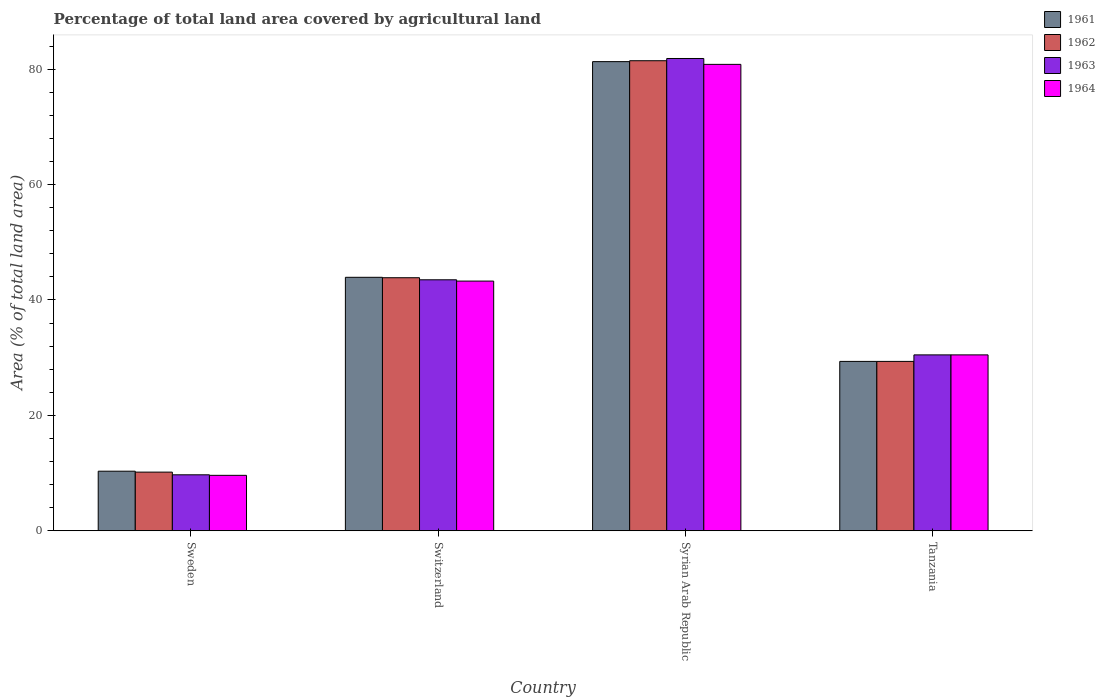How many different coloured bars are there?
Ensure brevity in your answer.  4. How many groups of bars are there?
Offer a terse response. 4. Are the number of bars on each tick of the X-axis equal?
Offer a terse response. Yes. What is the label of the 2nd group of bars from the left?
Offer a terse response. Switzerland. What is the percentage of agricultural land in 1963 in Tanzania?
Ensure brevity in your answer.  30.48. Across all countries, what is the maximum percentage of agricultural land in 1963?
Keep it short and to the point. 81.84. Across all countries, what is the minimum percentage of agricultural land in 1961?
Provide a succinct answer. 10.33. In which country was the percentage of agricultural land in 1962 maximum?
Provide a succinct answer. Syrian Arab Republic. In which country was the percentage of agricultural land in 1964 minimum?
Your answer should be compact. Sweden. What is the total percentage of agricultural land in 1964 in the graph?
Provide a short and direct response. 164.19. What is the difference between the percentage of agricultural land in 1964 in Sweden and that in Tanzania?
Ensure brevity in your answer.  -20.87. What is the difference between the percentage of agricultural land in 1962 in Switzerland and the percentage of agricultural land in 1964 in Syrian Arab Republic?
Your answer should be very brief. -36.97. What is the average percentage of agricultural land in 1964 per country?
Your response must be concise. 41.05. What is the difference between the percentage of agricultural land of/in 1963 and percentage of agricultural land of/in 1962 in Switzerland?
Ensure brevity in your answer.  -0.36. In how many countries, is the percentage of agricultural land in 1964 greater than 72 %?
Offer a terse response. 1. What is the ratio of the percentage of agricultural land in 1961 in Switzerland to that in Syrian Arab Republic?
Ensure brevity in your answer.  0.54. Is the percentage of agricultural land in 1963 in Sweden less than that in Switzerland?
Make the answer very short. Yes. Is the difference between the percentage of agricultural land in 1963 in Sweden and Switzerland greater than the difference between the percentage of agricultural land in 1962 in Sweden and Switzerland?
Make the answer very short. No. What is the difference between the highest and the second highest percentage of agricultural land in 1963?
Make the answer very short. 38.35. What is the difference between the highest and the lowest percentage of agricultural land in 1963?
Keep it short and to the point. 72.14. Is the sum of the percentage of agricultural land in 1961 in Sweden and Switzerland greater than the maximum percentage of agricultural land in 1963 across all countries?
Keep it short and to the point. No. Is it the case that in every country, the sum of the percentage of agricultural land in 1964 and percentage of agricultural land in 1961 is greater than the sum of percentage of agricultural land in 1962 and percentage of agricultural land in 1963?
Provide a short and direct response. No. What does the 2nd bar from the left in Switzerland represents?
Give a very brief answer. 1962. What does the 1st bar from the right in Sweden represents?
Provide a succinct answer. 1964. Are the values on the major ticks of Y-axis written in scientific E-notation?
Offer a very short reply. No. Does the graph contain any zero values?
Provide a succinct answer. No. What is the title of the graph?
Provide a succinct answer. Percentage of total land area covered by agricultural land. What is the label or title of the Y-axis?
Provide a succinct answer. Area (% of total land area). What is the Area (% of total land area) of 1961 in Sweden?
Keep it short and to the point. 10.33. What is the Area (% of total land area) in 1962 in Sweden?
Provide a succinct answer. 10.17. What is the Area (% of total land area) in 1963 in Sweden?
Your answer should be compact. 9.7. What is the Area (% of total land area) of 1964 in Sweden?
Offer a very short reply. 9.61. What is the Area (% of total land area) in 1961 in Switzerland?
Offer a terse response. 43.93. What is the Area (% of total land area) in 1962 in Switzerland?
Your response must be concise. 43.85. What is the Area (% of total land area) of 1963 in Switzerland?
Ensure brevity in your answer.  43.49. What is the Area (% of total land area) in 1964 in Switzerland?
Ensure brevity in your answer.  43.27. What is the Area (% of total land area) of 1961 in Syrian Arab Republic?
Your response must be concise. 81.3. What is the Area (% of total land area) of 1962 in Syrian Arab Republic?
Your response must be concise. 81.46. What is the Area (% of total land area) of 1963 in Syrian Arab Republic?
Offer a very short reply. 81.84. What is the Area (% of total land area) in 1964 in Syrian Arab Republic?
Provide a succinct answer. 80.82. What is the Area (% of total land area) in 1961 in Tanzania?
Provide a short and direct response. 29.35. What is the Area (% of total land area) of 1962 in Tanzania?
Your response must be concise. 29.35. What is the Area (% of total land area) of 1963 in Tanzania?
Give a very brief answer. 30.48. What is the Area (% of total land area) in 1964 in Tanzania?
Offer a terse response. 30.48. Across all countries, what is the maximum Area (% of total land area) of 1961?
Your answer should be compact. 81.3. Across all countries, what is the maximum Area (% of total land area) of 1962?
Make the answer very short. 81.46. Across all countries, what is the maximum Area (% of total land area) in 1963?
Provide a short and direct response. 81.84. Across all countries, what is the maximum Area (% of total land area) of 1964?
Keep it short and to the point. 80.82. Across all countries, what is the minimum Area (% of total land area) in 1961?
Your answer should be compact. 10.33. Across all countries, what is the minimum Area (% of total land area) of 1962?
Provide a short and direct response. 10.17. Across all countries, what is the minimum Area (% of total land area) in 1963?
Offer a terse response. 9.7. Across all countries, what is the minimum Area (% of total land area) of 1964?
Your response must be concise. 9.61. What is the total Area (% of total land area) in 1961 in the graph?
Provide a short and direct response. 164.9. What is the total Area (% of total land area) of 1962 in the graph?
Your response must be concise. 164.83. What is the total Area (% of total land area) of 1963 in the graph?
Make the answer very short. 165.52. What is the total Area (% of total land area) in 1964 in the graph?
Your answer should be very brief. 164.19. What is the difference between the Area (% of total land area) of 1961 in Sweden and that in Switzerland?
Keep it short and to the point. -33.6. What is the difference between the Area (% of total land area) in 1962 in Sweden and that in Switzerland?
Provide a succinct answer. -33.69. What is the difference between the Area (% of total land area) of 1963 in Sweden and that in Switzerland?
Make the answer very short. -33.79. What is the difference between the Area (% of total land area) in 1964 in Sweden and that in Switzerland?
Provide a short and direct response. -33.66. What is the difference between the Area (% of total land area) in 1961 in Sweden and that in Syrian Arab Republic?
Your response must be concise. -70.97. What is the difference between the Area (% of total land area) of 1962 in Sweden and that in Syrian Arab Republic?
Your response must be concise. -71.29. What is the difference between the Area (% of total land area) in 1963 in Sweden and that in Syrian Arab Republic?
Your response must be concise. -72.14. What is the difference between the Area (% of total land area) of 1964 in Sweden and that in Syrian Arab Republic?
Ensure brevity in your answer.  -71.22. What is the difference between the Area (% of total land area) of 1961 in Sweden and that in Tanzania?
Provide a succinct answer. -19.03. What is the difference between the Area (% of total land area) of 1962 in Sweden and that in Tanzania?
Make the answer very short. -19.18. What is the difference between the Area (% of total land area) of 1963 in Sweden and that in Tanzania?
Make the answer very short. -20.78. What is the difference between the Area (% of total land area) of 1964 in Sweden and that in Tanzania?
Keep it short and to the point. -20.87. What is the difference between the Area (% of total land area) of 1961 in Switzerland and that in Syrian Arab Republic?
Your response must be concise. -37.37. What is the difference between the Area (% of total land area) in 1962 in Switzerland and that in Syrian Arab Republic?
Provide a short and direct response. -37.6. What is the difference between the Area (% of total land area) of 1963 in Switzerland and that in Syrian Arab Republic?
Ensure brevity in your answer.  -38.35. What is the difference between the Area (% of total land area) in 1964 in Switzerland and that in Syrian Arab Republic?
Your answer should be compact. -37.55. What is the difference between the Area (% of total land area) of 1961 in Switzerland and that in Tanzania?
Provide a short and direct response. 14.57. What is the difference between the Area (% of total land area) of 1962 in Switzerland and that in Tanzania?
Your answer should be compact. 14.5. What is the difference between the Area (% of total land area) of 1963 in Switzerland and that in Tanzania?
Your answer should be very brief. 13.01. What is the difference between the Area (% of total land area) of 1964 in Switzerland and that in Tanzania?
Your answer should be compact. 12.79. What is the difference between the Area (% of total land area) in 1961 in Syrian Arab Republic and that in Tanzania?
Give a very brief answer. 51.95. What is the difference between the Area (% of total land area) of 1962 in Syrian Arab Republic and that in Tanzania?
Provide a short and direct response. 52.1. What is the difference between the Area (% of total land area) in 1963 in Syrian Arab Republic and that in Tanzania?
Make the answer very short. 51.36. What is the difference between the Area (% of total land area) of 1964 in Syrian Arab Republic and that in Tanzania?
Ensure brevity in your answer.  50.34. What is the difference between the Area (% of total land area) in 1961 in Sweden and the Area (% of total land area) in 1962 in Switzerland?
Provide a succinct answer. -33.53. What is the difference between the Area (% of total land area) of 1961 in Sweden and the Area (% of total land area) of 1963 in Switzerland?
Provide a succinct answer. -33.17. What is the difference between the Area (% of total land area) in 1961 in Sweden and the Area (% of total land area) in 1964 in Switzerland?
Give a very brief answer. -32.95. What is the difference between the Area (% of total land area) in 1962 in Sweden and the Area (% of total land area) in 1963 in Switzerland?
Give a very brief answer. -33.33. What is the difference between the Area (% of total land area) in 1962 in Sweden and the Area (% of total land area) in 1964 in Switzerland?
Make the answer very short. -33.1. What is the difference between the Area (% of total land area) of 1963 in Sweden and the Area (% of total land area) of 1964 in Switzerland?
Your answer should be compact. -33.57. What is the difference between the Area (% of total land area) in 1961 in Sweden and the Area (% of total land area) in 1962 in Syrian Arab Republic?
Provide a short and direct response. -71.13. What is the difference between the Area (% of total land area) of 1961 in Sweden and the Area (% of total land area) of 1963 in Syrian Arab Republic?
Your answer should be compact. -71.52. What is the difference between the Area (% of total land area) in 1961 in Sweden and the Area (% of total land area) in 1964 in Syrian Arab Republic?
Provide a succinct answer. -70.5. What is the difference between the Area (% of total land area) of 1962 in Sweden and the Area (% of total land area) of 1963 in Syrian Arab Republic?
Make the answer very short. -71.68. What is the difference between the Area (% of total land area) of 1962 in Sweden and the Area (% of total land area) of 1964 in Syrian Arab Republic?
Offer a terse response. -70.66. What is the difference between the Area (% of total land area) in 1963 in Sweden and the Area (% of total land area) in 1964 in Syrian Arab Republic?
Make the answer very short. -71.12. What is the difference between the Area (% of total land area) in 1961 in Sweden and the Area (% of total land area) in 1962 in Tanzania?
Your answer should be very brief. -19.03. What is the difference between the Area (% of total land area) in 1961 in Sweden and the Area (% of total land area) in 1963 in Tanzania?
Offer a terse response. -20.16. What is the difference between the Area (% of total land area) of 1961 in Sweden and the Area (% of total land area) of 1964 in Tanzania?
Give a very brief answer. -20.16. What is the difference between the Area (% of total land area) in 1962 in Sweden and the Area (% of total land area) in 1963 in Tanzania?
Offer a very short reply. -20.31. What is the difference between the Area (% of total land area) of 1962 in Sweden and the Area (% of total land area) of 1964 in Tanzania?
Offer a very short reply. -20.31. What is the difference between the Area (% of total land area) in 1963 in Sweden and the Area (% of total land area) in 1964 in Tanzania?
Offer a terse response. -20.78. What is the difference between the Area (% of total land area) of 1961 in Switzerland and the Area (% of total land area) of 1962 in Syrian Arab Republic?
Offer a terse response. -37.53. What is the difference between the Area (% of total land area) of 1961 in Switzerland and the Area (% of total land area) of 1963 in Syrian Arab Republic?
Offer a very short reply. -37.92. What is the difference between the Area (% of total land area) of 1961 in Switzerland and the Area (% of total land area) of 1964 in Syrian Arab Republic?
Give a very brief answer. -36.9. What is the difference between the Area (% of total land area) of 1962 in Switzerland and the Area (% of total land area) of 1963 in Syrian Arab Republic?
Your answer should be compact. -37.99. What is the difference between the Area (% of total land area) in 1962 in Switzerland and the Area (% of total land area) in 1964 in Syrian Arab Republic?
Offer a very short reply. -36.97. What is the difference between the Area (% of total land area) in 1963 in Switzerland and the Area (% of total land area) in 1964 in Syrian Arab Republic?
Make the answer very short. -37.33. What is the difference between the Area (% of total land area) of 1961 in Switzerland and the Area (% of total land area) of 1962 in Tanzania?
Your answer should be compact. 14.57. What is the difference between the Area (% of total land area) in 1961 in Switzerland and the Area (% of total land area) in 1963 in Tanzania?
Offer a terse response. 13.44. What is the difference between the Area (% of total land area) of 1961 in Switzerland and the Area (% of total land area) of 1964 in Tanzania?
Your answer should be compact. 13.44. What is the difference between the Area (% of total land area) of 1962 in Switzerland and the Area (% of total land area) of 1963 in Tanzania?
Your response must be concise. 13.37. What is the difference between the Area (% of total land area) in 1962 in Switzerland and the Area (% of total land area) in 1964 in Tanzania?
Keep it short and to the point. 13.37. What is the difference between the Area (% of total land area) of 1963 in Switzerland and the Area (% of total land area) of 1964 in Tanzania?
Provide a succinct answer. 13.01. What is the difference between the Area (% of total land area) of 1961 in Syrian Arab Republic and the Area (% of total land area) of 1962 in Tanzania?
Keep it short and to the point. 51.95. What is the difference between the Area (% of total land area) of 1961 in Syrian Arab Republic and the Area (% of total land area) of 1963 in Tanzania?
Offer a terse response. 50.82. What is the difference between the Area (% of total land area) of 1961 in Syrian Arab Republic and the Area (% of total land area) of 1964 in Tanzania?
Ensure brevity in your answer.  50.82. What is the difference between the Area (% of total land area) of 1962 in Syrian Arab Republic and the Area (% of total land area) of 1963 in Tanzania?
Ensure brevity in your answer.  50.98. What is the difference between the Area (% of total land area) in 1962 in Syrian Arab Republic and the Area (% of total land area) in 1964 in Tanzania?
Ensure brevity in your answer.  50.98. What is the difference between the Area (% of total land area) in 1963 in Syrian Arab Republic and the Area (% of total land area) in 1964 in Tanzania?
Your answer should be compact. 51.36. What is the average Area (% of total land area) in 1961 per country?
Your answer should be very brief. 41.23. What is the average Area (% of total land area) in 1962 per country?
Your answer should be very brief. 41.21. What is the average Area (% of total land area) in 1963 per country?
Your answer should be very brief. 41.38. What is the average Area (% of total land area) in 1964 per country?
Offer a terse response. 41.05. What is the difference between the Area (% of total land area) in 1961 and Area (% of total land area) in 1962 in Sweden?
Ensure brevity in your answer.  0.16. What is the difference between the Area (% of total land area) of 1961 and Area (% of total land area) of 1963 in Sweden?
Make the answer very short. 0.62. What is the difference between the Area (% of total land area) in 1961 and Area (% of total land area) in 1964 in Sweden?
Keep it short and to the point. 0.72. What is the difference between the Area (% of total land area) in 1962 and Area (% of total land area) in 1963 in Sweden?
Keep it short and to the point. 0.47. What is the difference between the Area (% of total land area) of 1962 and Area (% of total land area) of 1964 in Sweden?
Give a very brief answer. 0.56. What is the difference between the Area (% of total land area) in 1963 and Area (% of total land area) in 1964 in Sweden?
Provide a short and direct response. 0.09. What is the difference between the Area (% of total land area) in 1961 and Area (% of total land area) in 1962 in Switzerland?
Your response must be concise. 0.07. What is the difference between the Area (% of total land area) of 1961 and Area (% of total land area) of 1963 in Switzerland?
Provide a short and direct response. 0.43. What is the difference between the Area (% of total land area) of 1961 and Area (% of total land area) of 1964 in Switzerland?
Give a very brief answer. 0.66. What is the difference between the Area (% of total land area) of 1962 and Area (% of total land area) of 1963 in Switzerland?
Keep it short and to the point. 0.36. What is the difference between the Area (% of total land area) in 1962 and Area (% of total land area) in 1964 in Switzerland?
Give a very brief answer. 0.58. What is the difference between the Area (% of total land area) of 1963 and Area (% of total land area) of 1964 in Switzerland?
Ensure brevity in your answer.  0.22. What is the difference between the Area (% of total land area) in 1961 and Area (% of total land area) in 1962 in Syrian Arab Republic?
Offer a very short reply. -0.16. What is the difference between the Area (% of total land area) in 1961 and Area (% of total land area) in 1963 in Syrian Arab Republic?
Your response must be concise. -0.54. What is the difference between the Area (% of total land area) in 1961 and Area (% of total land area) in 1964 in Syrian Arab Republic?
Your response must be concise. 0.47. What is the difference between the Area (% of total land area) in 1962 and Area (% of total land area) in 1963 in Syrian Arab Republic?
Your response must be concise. -0.39. What is the difference between the Area (% of total land area) of 1962 and Area (% of total land area) of 1964 in Syrian Arab Republic?
Offer a very short reply. 0.63. What is the difference between the Area (% of total land area) of 1963 and Area (% of total land area) of 1964 in Syrian Arab Republic?
Provide a short and direct response. 1.02. What is the difference between the Area (% of total land area) of 1961 and Area (% of total land area) of 1963 in Tanzania?
Keep it short and to the point. -1.13. What is the difference between the Area (% of total land area) of 1961 and Area (% of total land area) of 1964 in Tanzania?
Keep it short and to the point. -1.13. What is the difference between the Area (% of total land area) of 1962 and Area (% of total land area) of 1963 in Tanzania?
Give a very brief answer. -1.13. What is the difference between the Area (% of total land area) in 1962 and Area (% of total land area) in 1964 in Tanzania?
Offer a terse response. -1.13. What is the difference between the Area (% of total land area) of 1963 and Area (% of total land area) of 1964 in Tanzania?
Offer a very short reply. 0. What is the ratio of the Area (% of total land area) in 1961 in Sweden to that in Switzerland?
Keep it short and to the point. 0.24. What is the ratio of the Area (% of total land area) in 1962 in Sweden to that in Switzerland?
Offer a very short reply. 0.23. What is the ratio of the Area (% of total land area) in 1963 in Sweden to that in Switzerland?
Your answer should be very brief. 0.22. What is the ratio of the Area (% of total land area) in 1964 in Sweden to that in Switzerland?
Your answer should be compact. 0.22. What is the ratio of the Area (% of total land area) of 1961 in Sweden to that in Syrian Arab Republic?
Provide a succinct answer. 0.13. What is the ratio of the Area (% of total land area) in 1962 in Sweden to that in Syrian Arab Republic?
Provide a succinct answer. 0.12. What is the ratio of the Area (% of total land area) of 1963 in Sweden to that in Syrian Arab Republic?
Provide a short and direct response. 0.12. What is the ratio of the Area (% of total land area) in 1964 in Sweden to that in Syrian Arab Republic?
Provide a short and direct response. 0.12. What is the ratio of the Area (% of total land area) of 1961 in Sweden to that in Tanzania?
Give a very brief answer. 0.35. What is the ratio of the Area (% of total land area) in 1962 in Sweden to that in Tanzania?
Offer a very short reply. 0.35. What is the ratio of the Area (% of total land area) in 1963 in Sweden to that in Tanzania?
Ensure brevity in your answer.  0.32. What is the ratio of the Area (% of total land area) in 1964 in Sweden to that in Tanzania?
Give a very brief answer. 0.32. What is the ratio of the Area (% of total land area) of 1961 in Switzerland to that in Syrian Arab Republic?
Ensure brevity in your answer.  0.54. What is the ratio of the Area (% of total land area) in 1962 in Switzerland to that in Syrian Arab Republic?
Make the answer very short. 0.54. What is the ratio of the Area (% of total land area) of 1963 in Switzerland to that in Syrian Arab Republic?
Provide a succinct answer. 0.53. What is the ratio of the Area (% of total land area) of 1964 in Switzerland to that in Syrian Arab Republic?
Your answer should be very brief. 0.54. What is the ratio of the Area (% of total land area) of 1961 in Switzerland to that in Tanzania?
Your answer should be very brief. 1.5. What is the ratio of the Area (% of total land area) in 1962 in Switzerland to that in Tanzania?
Make the answer very short. 1.49. What is the ratio of the Area (% of total land area) of 1963 in Switzerland to that in Tanzania?
Your response must be concise. 1.43. What is the ratio of the Area (% of total land area) of 1964 in Switzerland to that in Tanzania?
Keep it short and to the point. 1.42. What is the ratio of the Area (% of total land area) in 1961 in Syrian Arab Republic to that in Tanzania?
Provide a succinct answer. 2.77. What is the ratio of the Area (% of total land area) of 1962 in Syrian Arab Republic to that in Tanzania?
Offer a terse response. 2.78. What is the ratio of the Area (% of total land area) of 1963 in Syrian Arab Republic to that in Tanzania?
Make the answer very short. 2.69. What is the ratio of the Area (% of total land area) of 1964 in Syrian Arab Republic to that in Tanzania?
Your answer should be compact. 2.65. What is the difference between the highest and the second highest Area (% of total land area) of 1961?
Keep it short and to the point. 37.37. What is the difference between the highest and the second highest Area (% of total land area) of 1962?
Make the answer very short. 37.6. What is the difference between the highest and the second highest Area (% of total land area) in 1963?
Make the answer very short. 38.35. What is the difference between the highest and the second highest Area (% of total land area) of 1964?
Provide a succinct answer. 37.55. What is the difference between the highest and the lowest Area (% of total land area) of 1961?
Keep it short and to the point. 70.97. What is the difference between the highest and the lowest Area (% of total land area) in 1962?
Keep it short and to the point. 71.29. What is the difference between the highest and the lowest Area (% of total land area) in 1963?
Provide a succinct answer. 72.14. What is the difference between the highest and the lowest Area (% of total land area) in 1964?
Your answer should be very brief. 71.22. 